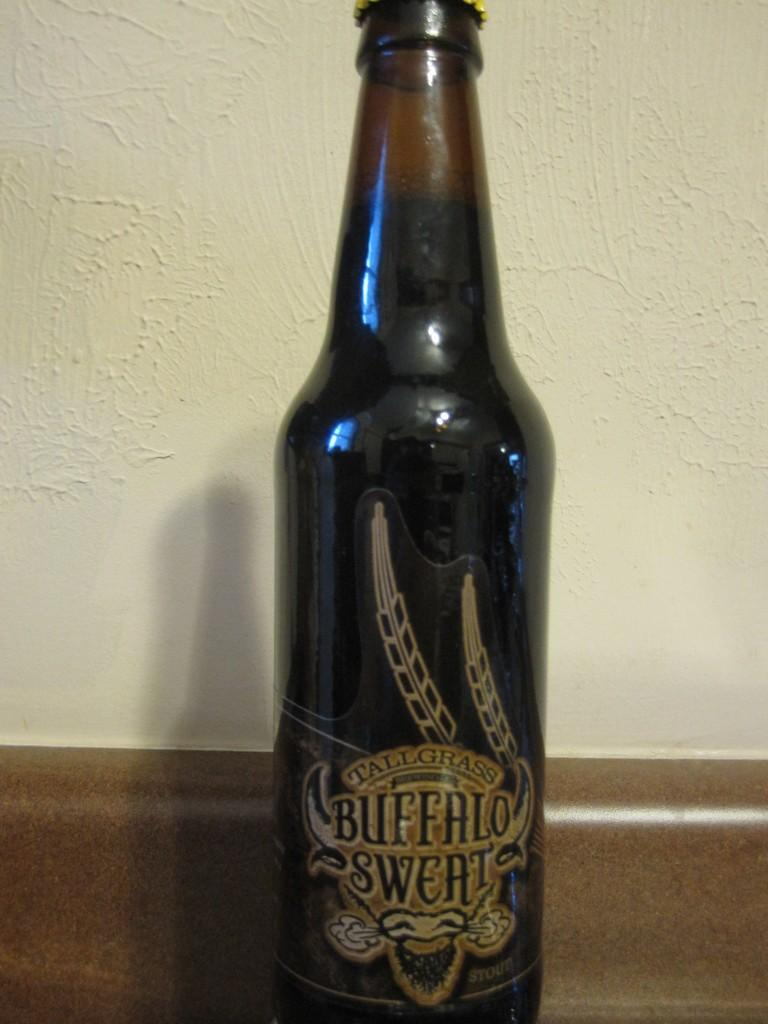What object can be seen in the picture? There is a bottle in the picture. What is written on the bottle? The bottle has the words "buffalo sweat" written on it. What color is the bottle? The bottle is black in color. What can be seen in the background of the picture? There is a wall in the background of the picture. How many dogs are present in the image? There are no dogs present in the image. What organization is responsible for the bottle in the image? The image does not provide information about any organization responsible for the bottle. 